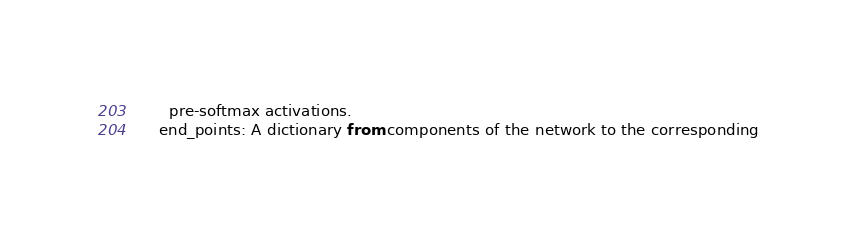<code> <loc_0><loc_0><loc_500><loc_500><_Python_>      pre-softmax activations.
    end_points: A dictionary from components of the network to the corresponding</code> 